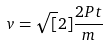<formula> <loc_0><loc_0><loc_500><loc_500>v = \sqrt { [ } 2 ] { \frac { 2 P t } { m } }</formula> 